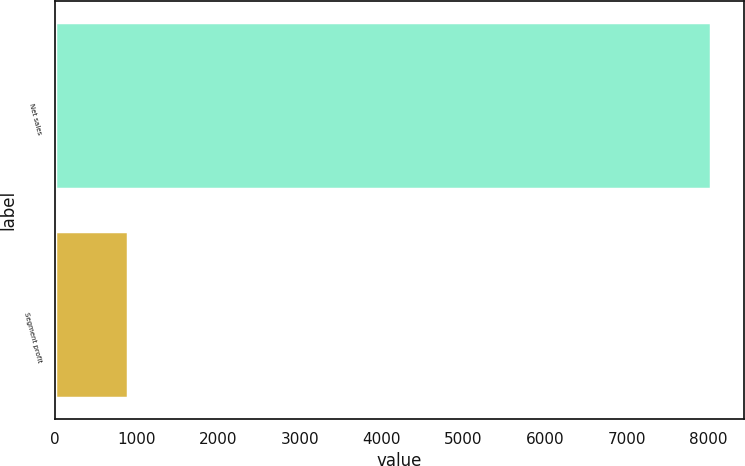Convert chart. <chart><loc_0><loc_0><loc_500><loc_500><bar_chart><fcel>Net sales<fcel>Segment profit<nl><fcel>8031<fcel>894<nl></chart> 